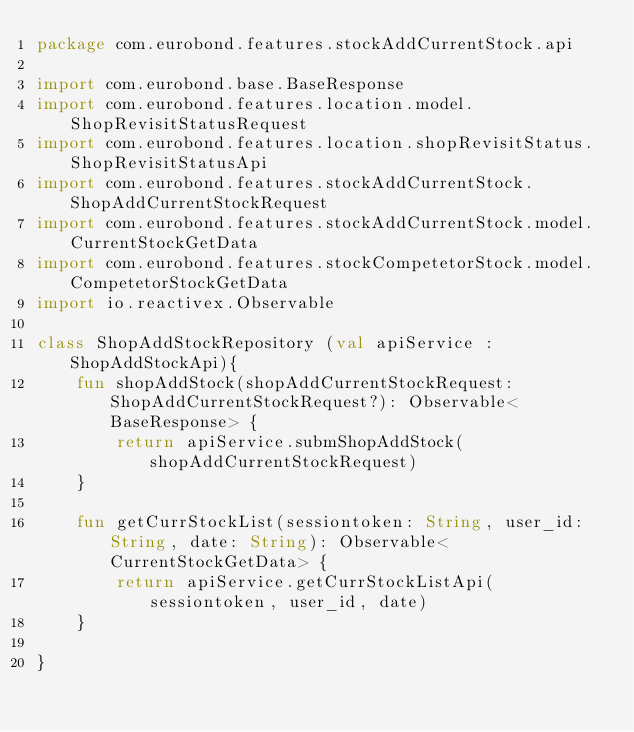<code> <loc_0><loc_0><loc_500><loc_500><_Kotlin_>package com.eurobond.features.stockAddCurrentStock.api

import com.eurobond.base.BaseResponse
import com.eurobond.features.location.model.ShopRevisitStatusRequest
import com.eurobond.features.location.shopRevisitStatus.ShopRevisitStatusApi
import com.eurobond.features.stockAddCurrentStock.ShopAddCurrentStockRequest
import com.eurobond.features.stockAddCurrentStock.model.CurrentStockGetData
import com.eurobond.features.stockCompetetorStock.model.CompetetorStockGetData
import io.reactivex.Observable

class ShopAddStockRepository (val apiService : ShopAddStockApi){
    fun shopAddStock(shopAddCurrentStockRequest: ShopAddCurrentStockRequest?): Observable<BaseResponse> {
        return apiService.submShopAddStock(shopAddCurrentStockRequest)
    }

    fun getCurrStockList(sessiontoken: String, user_id: String, date: String): Observable<CurrentStockGetData> {
        return apiService.getCurrStockListApi(sessiontoken, user_id, date)
    }

}</code> 